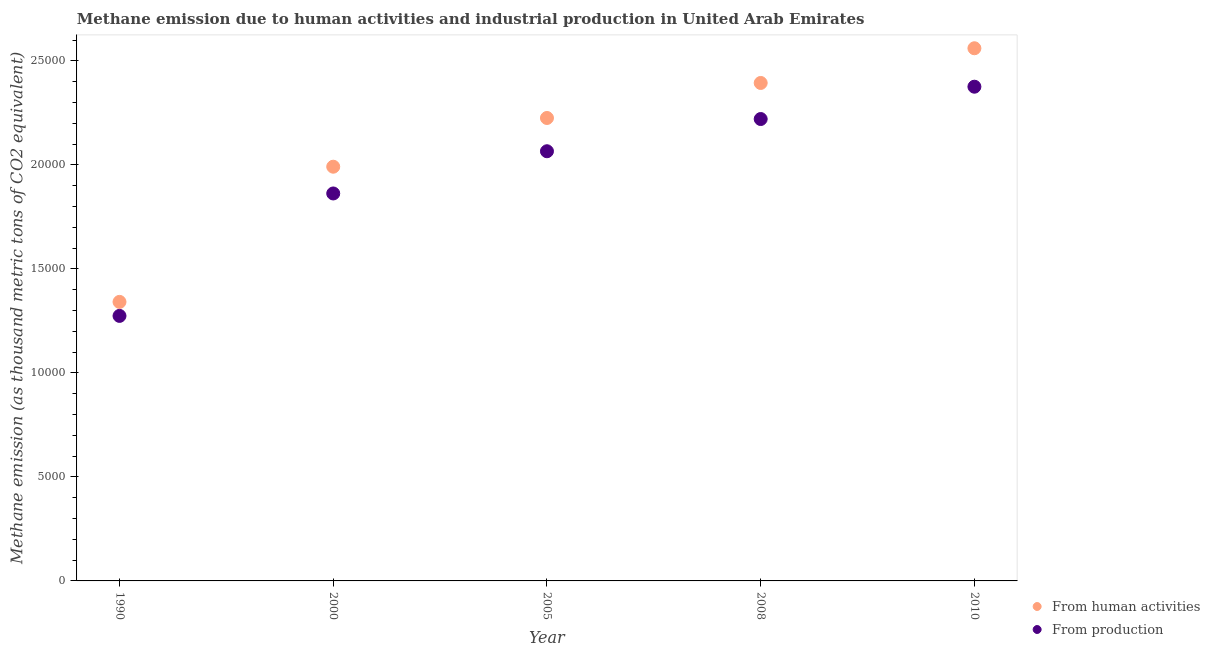How many different coloured dotlines are there?
Ensure brevity in your answer.  2. Is the number of dotlines equal to the number of legend labels?
Your answer should be very brief. Yes. What is the amount of emissions from human activities in 2010?
Ensure brevity in your answer.  2.56e+04. Across all years, what is the maximum amount of emissions from human activities?
Your response must be concise. 2.56e+04. Across all years, what is the minimum amount of emissions generated from industries?
Offer a terse response. 1.27e+04. In which year was the amount of emissions generated from industries minimum?
Provide a succinct answer. 1990. What is the total amount of emissions from human activities in the graph?
Give a very brief answer. 1.05e+05. What is the difference between the amount of emissions from human activities in 2005 and that in 2010?
Keep it short and to the point. -3352. What is the difference between the amount of emissions from human activities in 1990 and the amount of emissions generated from industries in 2005?
Your answer should be very brief. -7242.1. What is the average amount of emissions from human activities per year?
Provide a short and direct response. 2.10e+04. In the year 1990, what is the difference between the amount of emissions from human activities and amount of emissions generated from industries?
Give a very brief answer. 673.2. What is the ratio of the amount of emissions generated from industries in 1990 to that in 2008?
Your answer should be very brief. 0.57. Is the amount of emissions generated from industries in 2000 less than that in 2005?
Give a very brief answer. Yes. What is the difference between the highest and the second highest amount of emissions generated from industries?
Your answer should be very brief. 1554. What is the difference between the highest and the lowest amount of emissions generated from industries?
Your answer should be compact. 1.10e+04. Is the sum of the amount of emissions generated from industries in 1990 and 2000 greater than the maximum amount of emissions from human activities across all years?
Ensure brevity in your answer.  Yes. Does the amount of emissions from human activities monotonically increase over the years?
Keep it short and to the point. Yes. Is the amount of emissions generated from industries strictly less than the amount of emissions from human activities over the years?
Provide a short and direct response. Yes. How many dotlines are there?
Give a very brief answer. 2. What is the difference between two consecutive major ticks on the Y-axis?
Offer a very short reply. 5000. Are the values on the major ticks of Y-axis written in scientific E-notation?
Your answer should be compact. No. Where does the legend appear in the graph?
Make the answer very short. Bottom right. How are the legend labels stacked?
Offer a terse response. Vertical. What is the title of the graph?
Offer a terse response. Methane emission due to human activities and industrial production in United Arab Emirates. What is the label or title of the Y-axis?
Offer a very short reply. Methane emission (as thousand metric tons of CO2 equivalent). What is the Methane emission (as thousand metric tons of CO2 equivalent) of From human activities in 1990?
Offer a terse response. 1.34e+04. What is the Methane emission (as thousand metric tons of CO2 equivalent) in From production in 1990?
Make the answer very short. 1.27e+04. What is the Methane emission (as thousand metric tons of CO2 equivalent) in From human activities in 2000?
Offer a very short reply. 1.99e+04. What is the Methane emission (as thousand metric tons of CO2 equivalent) of From production in 2000?
Keep it short and to the point. 1.86e+04. What is the Methane emission (as thousand metric tons of CO2 equivalent) in From human activities in 2005?
Make the answer very short. 2.23e+04. What is the Methane emission (as thousand metric tons of CO2 equivalent) of From production in 2005?
Offer a terse response. 2.07e+04. What is the Methane emission (as thousand metric tons of CO2 equivalent) of From human activities in 2008?
Your answer should be compact. 2.39e+04. What is the Methane emission (as thousand metric tons of CO2 equivalent) of From production in 2008?
Ensure brevity in your answer.  2.22e+04. What is the Methane emission (as thousand metric tons of CO2 equivalent) of From human activities in 2010?
Make the answer very short. 2.56e+04. What is the Methane emission (as thousand metric tons of CO2 equivalent) of From production in 2010?
Your answer should be compact. 2.38e+04. Across all years, what is the maximum Methane emission (as thousand metric tons of CO2 equivalent) in From human activities?
Ensure brevity in your answer.  2.56e+04. Across all years, what is the maximum Methane emission (as thousand metric tons of CO2 equivalent) in From production?
Keep it short and to the point. 2.38e+04. Across all years, what is the minimum Methane emission (as thousand metric tons of CO2 equivalent) in From human activities?
Keep it short and to the point. 1.34e+04. Across all years, what is the minimum Methane emission (as thousand metric tons of CO2 equivalent) in From production?
Offer a terse response. 1.27e+04. What is the total Methane emission (as thousand metric tons of CO2 equivalent) in From human activities in the graph?
Offer a very short reply. 1.05e+05. What is the total Methane emission (as thousand metric tons of CO2 equivalent) in From production in the graph?
Ensure brevity in your answer.  9.80e+04. What is the difference between the Methane emission (as thousand metric tons of CO2 equivalent) of From human activities in 1990 and that in 2000?
Your response must be concise. -6499. What is the difference between the Methane emission (as thousand metric tons of CO2 equivalent) in From production in 1990 and that in 2000?
Offer a terse response. -5885.7. What is the difference between the Methane emission (as thousand metric tons of CO2 equivalent) in From human activities in 1990 and that in 2005?
Make the answer very short. -8841.4. What is the difference between the Methane emission (as thousand metric tons of CO2 equivalent) of From production in 1990 and that in 2005?
Keep it short and to the point. -7915.3. What is the difference between the Methane emission (as thousand metric tons of CO2 equivalent) in From human activities in 1990 and that in 2008?
Make the answer very short. -1.05e+04. What is the difference between the Methane emission (as thousand metric tons of CO2 equivalent) of From production in 1990 and that in 2008?
Your answer should be compact. -9464.3. What is the difference between the Methane emission (as thousand metric tons of CO2 equivalent) in From human activities in 1990 and that in 2010?
Offer a very short reply. -1.22e+04. What is the difference between the Methane emission (as thousand metric tons of CO2 equivalent) in From production in 1990 and that in 2010?
Make the answer very short. -1.10e+04. What is the difference between the Methane emission (as thousand metric tons of CO2 equivalent) of From human activities in 2000 and that in 2005?
Keep it short and to the point. -2342.4. What is the difference between the Methane emission (as thousand metric tons of CO2 equivalent) in From production in 2000 and that in 2005?
Ensure brevity in your answer.  -2029.6. What is the difference between the Methane emission (as thousand metric tons of CO2 equivalent) of From human activities in 2000 and that in 2008?
Ensure brevity in your answer.  -4025.9. What is the difference between the Methane emission (as thousand metric tons of CO2 equivalent) in From production in 2000 and that in 2008?
Offer a very short reply. -3578.6. What is the difference between the Methane emission (as thousand metric tons of CO2 equivalent) of From human activities in 2000 and that in 2010?
Provide a short and direct response. -5694.4. What is the difference between the Methane emission (as thousand metric tons of CO2 equivalent) in From production in 2000 and that in 2010?
Your response must be concise. -5132.6. What is the difference between the Methane emission (as thousand metric tons of CO2 equivalent) of From human activities in 2005 and that in 2008?
Make the answer very short. -1683.5. What is the difference between the Methane emission (as thousand metric tons of CO2 equivalent) of From production in 2005 and that in 2008?
Provide a succinct answer. -1549. What is the difference between the Methane emission (as thousand metric tons of CO2 equivalent) in From human activities in 2005 and that in 2010?
Offer a terse response. -3352. What is the difference between the Methane emission (as thousand metric tons of CO2 equivalent) of From production in 2005 and that in 2010?
Your response must be concise. -3103. What is the difference between the Methane emission (as thousand metric tons of CO2 equivalent) in From human activities in 2008 and that in 2010?
Offer a terse response. -1668.5. What is the difference between the Methane emission (as thousand metric tons of CO2 equivalent) of From production in 2008 and that in 2010?
Provide a short and direct response. -1554. What is the difference between the Methane emission (as thousand metric tons of CO2 equivalent) in From human activities in 1990 and the Methane emission (as thousand metric tons of CO2 equivalent) in From production in 2000?
Make the answer very short. -5212.5. What is the difference between the Methane emission (as thousand metric tons of CO2 equivalent) in From human activities in 1990 and the Methane emission (as thousand metric tons of CO2 equivalent) in From production in 2005?
Provide a short and direct response. -7242.1. What is the difference between the Methane emission (as thousand metric tons of CO2 equivalent) of From human activities in 1990 and the Methane emission (as thousand metric tons of CO2 equivalent) of From production in 2008?
Your answer should be compact. -8791.1. What is the difference between the Methane emission (as thousand metric tons of CO2 equivalent) of From human activities in 1990 and the Methane emission (as thousand metric tons of CO2 equivalent) of From production in 2010?
Your answer should be very brief. -1.03e+04. What is the difference between the Methane emission (as thousand metric tons of CO2 equivalent) of From human activities in 2000 and the Methane emission (as thousand metric tons of CO2 equivalent) of From production in 2005?
Keep it short and to the point. -743.1. What is the difference between the Methane emission (as thousand metric tons of CO2 equivalent) of From human activities in 2000 and the Methane emission (as thousand metric tons of CO2 equivalent) of From production in 2008?
Offer a very short reply. -2292.1. What is the difference between the Methane emission (as thousand metric tons of CO2 equivalent) in From human activities in 2000 and the Methane emission (as thousand metric tons of CO2 equivalent) in From production in 2010?
Provide a succinct answer. -3846.1. What is the difference between the Methane emission (as thousand metric tons of CO2 equivalent) in From human activities in 2005 and the Methane emission (as thousand metric tons of CO2 equivalent) in From production in 2008?
Keep it short and to the point. 50.3. What is the difference between the Methane emission (as thousand metric tons of CO2 equivalent) in From human activities in 2005 and the Methane emission (as thousand metric tons of CO2 equivalent) in From production in 2010?
Make the answer very short. -1503.7. What is the difference between the Methane emission (as thousand metric tons of CO2 equivalent) of From human activities in 2008 and the Methane emission (as thousand metric tons of CO2 equivalent) of From production in 2010?
Make the answer very short. 179.8. What is the average Methane emission (as thousand metric tons of CO2 equivalent) in From human activities per year?
Offer a terse response. 2.10e+04. What is the average Methane emission (as thousand metric tons of CO2 equivalent) in From production per year?
Your response must be concise. 1.96e+04. In the year 1990, what is the difference between the Methane emission (as thousand metric tons of CO2 equivalent) of From human activities and Methane emission (as thousand metric tons of CO2 equivalent) of From production?
Give a very brief answer. 673.2. In the year 2000, what is the difference between the Methane emission (as thousand metric tons of CO2 equivalent) in From human activities and Methane emission (as thousand metric tons of CO2 equivalent) in From production?
Offer a very short reply. 1286.5. In the year 2005, what is the difference between the Methane emission (as thousand metric tons of CO2 equivalent) in From human activities and Methane emission (as thousand metric tons of CO2 equivalent) in From production?
Provide a succinct answer. 1599.3. In the year 2008, what is the difference between the Methane emission (as thousand metric tons of CO2 equivalent) of From human activities and Methane emission (as thousand metric tons of CO2 equivalent) of From production?
Make the answer very short. 1733.8. In the year 2010, what is the difference between the Methane emission (as thousand metric tons of CO2 equivalent) of From human activities and Methane emission (as thousand metric tons of CO2 equivalent) of From production?
Provide a short and direct response. 1848.3. What is the ratio of the Methane emission (as thousand metric tons of CO2 equivalent) in From human activities in 1990 to that in 2000?
Make the answer very short. 0.67. What is the ratio of the Methane emission (as thousand metric tons of CO2 equivalent) of From production in 1990 to that in 2000?
Keep it short and to the point. 0.68. What is the ratio of the Methane emission (as thousand metric tons of CO2 equivalent) in From human activities in 1990 to that in 2005?
Provide a succinct answer. 0.6. What is the ratio of the Methane emission (as thousand metric tons of CO2 equivalent) of From production in 1990 to that in 2005?
Give a very brief answer. 0.62. What is the ratio of the Methane emission (as thousand metric tons of CO2 equivalent) of From human activities in 1990 to that in 2008?
Offer a terse response. 0.56. What is the ratio of the Methane emission (as thousand metric tons of CO2 equivalent) in From production in 1990 to that in 2008?
Ensure brevity in your answer.  0.57. What is the ratio of the Methane emission (as thousand metric tons of CO2 equivalent) of From human activities in 1990 to that in 2010?
Ensure brevity in your answer.  0.52. What is the ratio of the Methane emission (as thousand metric tons of CO2 equivalent) in From production in 1990 to that in 2010?
Give a very brief answer. 0.54. What is the ratio of the Methane emission (as thousand metric tons of CO2 equivalent) of From human activities in 2000 to that in 2005?
Keep it short and to the point. 0.89. What is the ratio of the Methane emission (as thousand metric tons of CO2 equivalent) of From production in 2000 to that in 2005?
Your response must be concise. 0.9. What is the ratio of the Methane emission (as thousand metric tons of CO2 equivalent) of From human activities in 2000 to that in 2008?
Your response must be concise. 0.83. What is the ratio of the Methane emission (as thousand metric tons of CO2 equivalent) of From production in 2000 to that in 2008?
Keep it short and to the point. 0.84. What is the ratio of the Methane emission (as thousand metric tons of CO2 equivalent) of From human activities in 2000 to that in 2010?
Offer a terse response. 0.78. What is the ratio of the Methane emission (as thousand metric tons of CO2 equivalent) in From production in 2000 to that in 2010?
Your answer should be very brief. 0.78. What is the ratio of the Methane emission (as thousand metric tons of CO2 equivalent) in From human activities in 2005 to that in 2008?
Give a very brief answer. 0.93. What is the ratio of the Methane emission (as thousand metric tons of CO2 equivalent) in From production in 2005 to that in 2008?
Keep it short and to the point. 0.93. What is the ratio of the Methane emission (as thousand metric tons of CO2 equivalent) of From human activities in 2005 to that in 2010?
Your answer should be compact. 0.87. What is the ratio of the Methane emission (as thousand metric tons of CO2 equivalent) in From production in 2005 to that in 2010?
Ensure brevity in your answer.  0.87. What is the ratio of the Methane emission (as thousand metric tons of CO2 equivalent) in From human activities in 2008 to that in 2010?
Make the answer very short. 0.93. What is the ratio of the Methane emission (as thousand metric tons of CO2 equivalent) in From production in 2008 to that in 2010?
Make the answer very short. 0.93. What is the difference between the highest and the second highest Methane emission (as thousand metric tons of CO2 equivalent) in From human activities?
Keep it short and to the point. 1668.5. What is the difference between the highest and the second highest Methane emission (as thousand metric tons of CO2 equivalent) of From production?
Your response must be concise. 1554. What is the difference between the highest and the lowest Methane emission (as thousand metric tons of CO2 equivalent) of From human activities?
Provide a succinct answer. 1.22e+04. What is the difference between the highest and the lowest Methane emission (as thousand metric tons of CO2 equivalent) of From production?
Provide a short and direct response. 1.10e+04. 